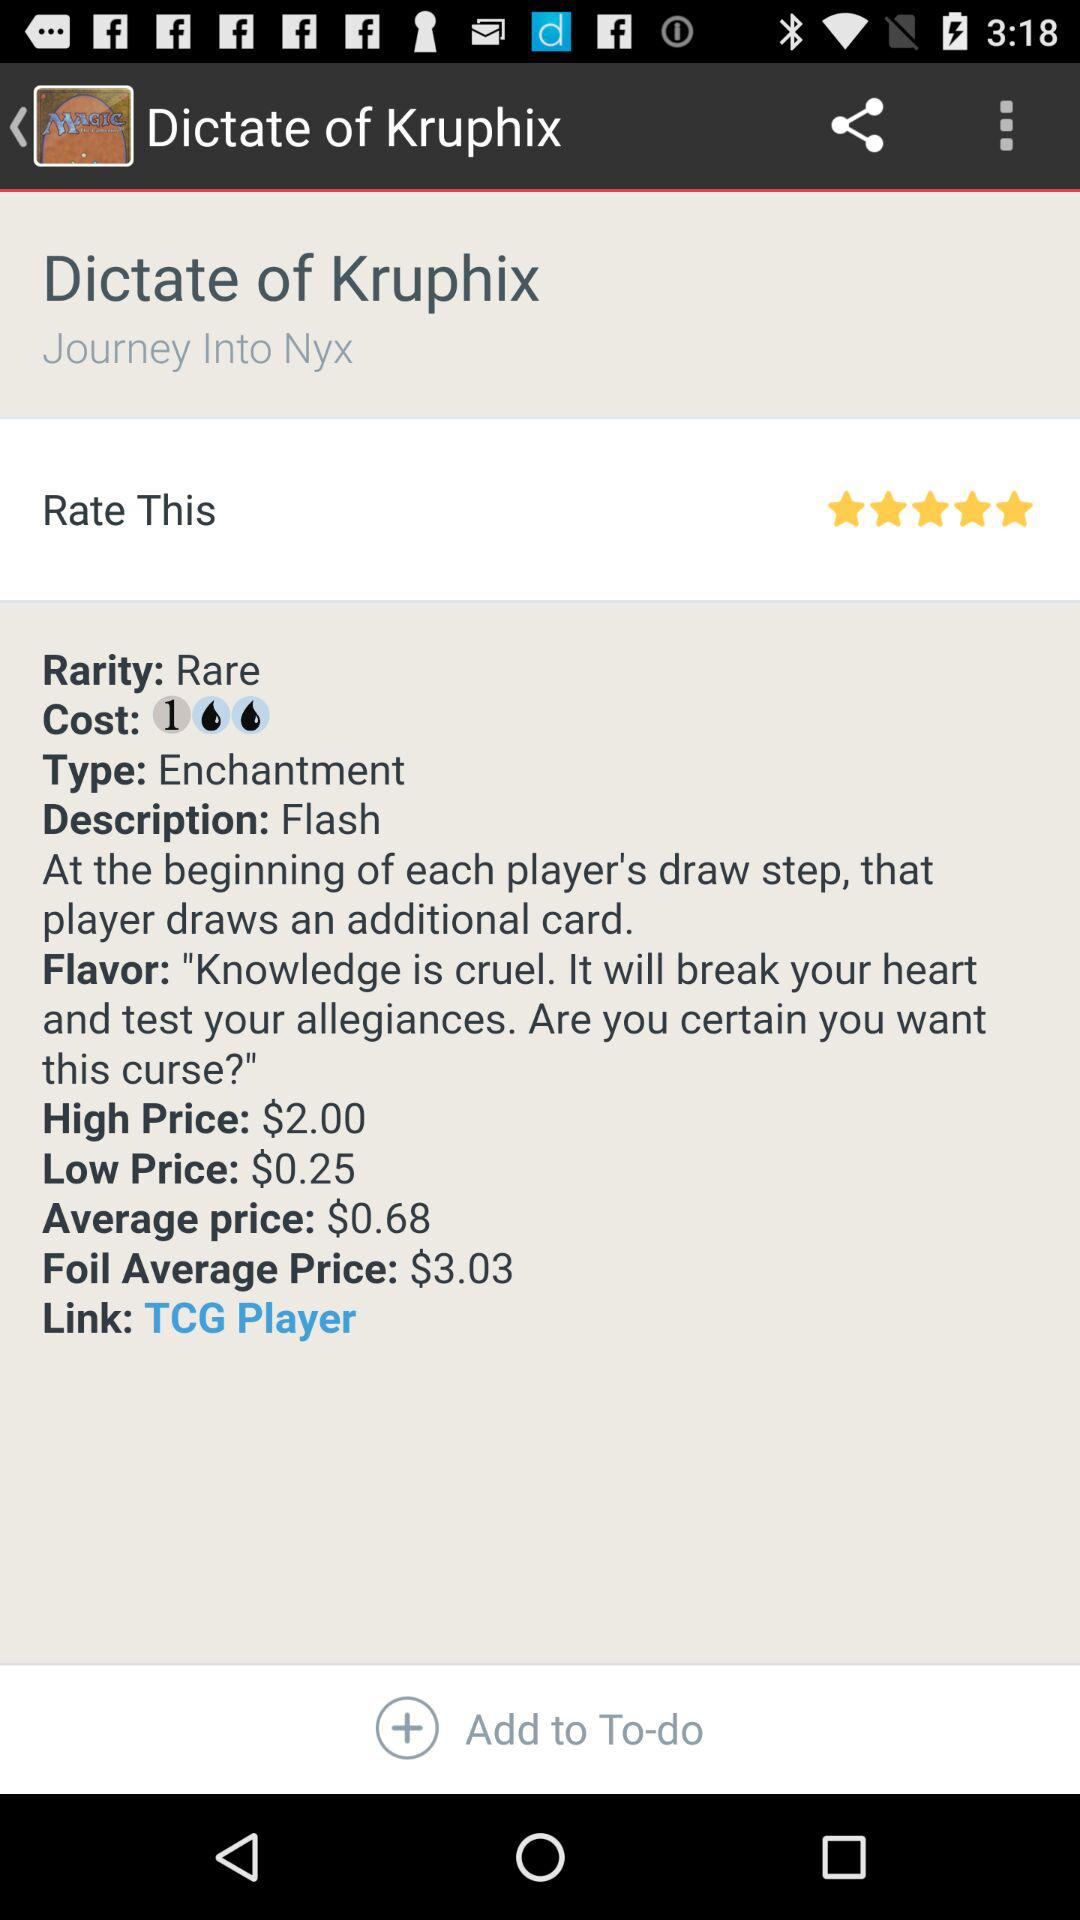What is the high price? The high price is $2. 